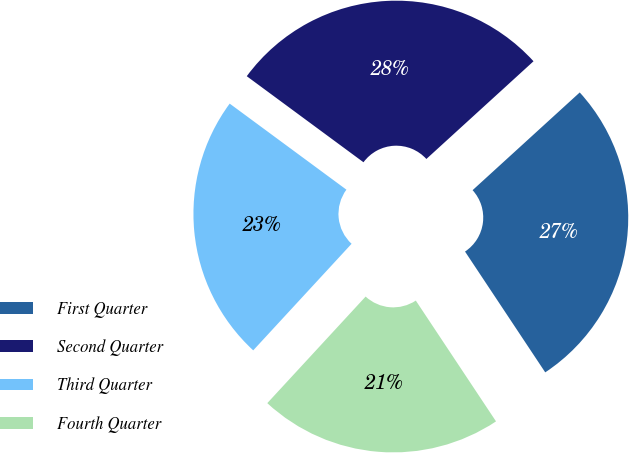Convert chart to OTSL. <chart><loc_0><loc_0><loc_500><loc_500><pie_chart><fcel>First Quarter<fcel>Second Quarter<fcel>Third Quarter<fcel>Fourth Quarter<nl><fcel>27.44%<fcel>28.12%<fcel>23.25%<fcel>21.19%<nl></chart> 